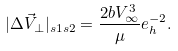Convert formula to latex. <formula><loc_0><loc_0><loc_500><loc_500>| \Delta \vec { V } _ { \bot } | _ { s 1 s 2 } = \frac { 2 b V _ { \infty } ^ { 3 } } { \mu } e _ { h } ^ { - 2 } .</formula> 